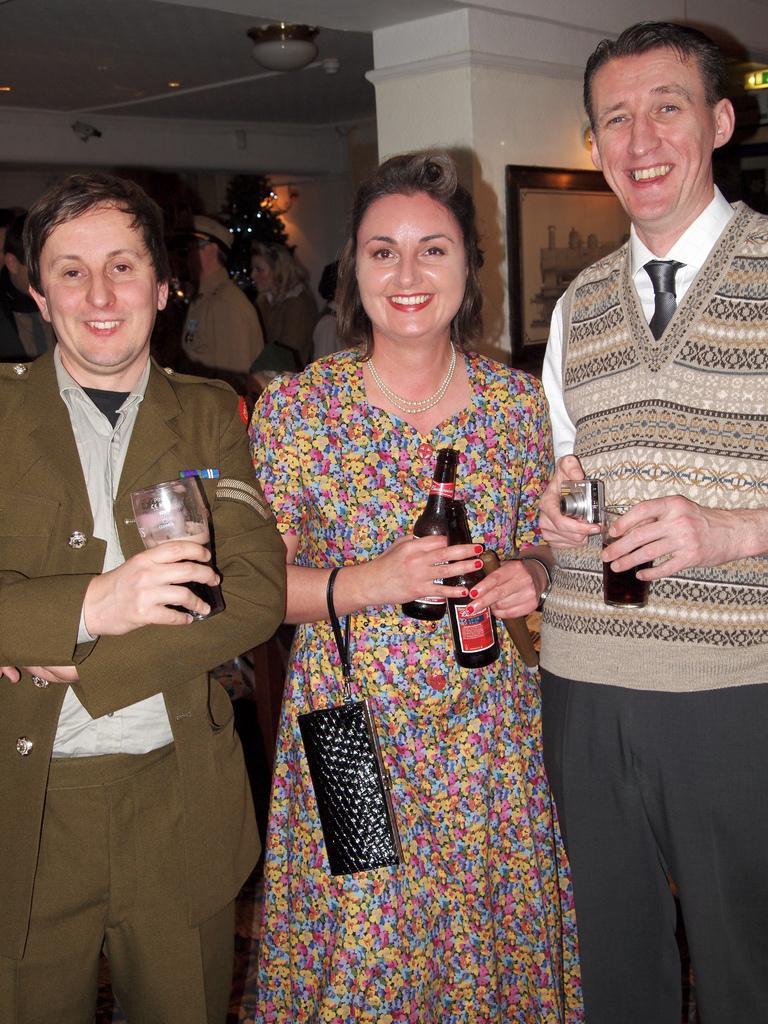Please provide a concise description of this image. In the image there is a woman standing in between of two men holding bottles, the man holding wine glasses and behind there are few persons visible and a photo frame on the wall. 